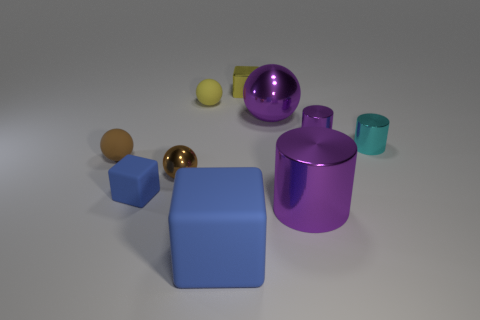Subtract all cyan cubes. How many purple cylinders are left? 2 Subtract 1 balls. How many balls are left? 3 Subtract all yellow balls. How many balls are left? 3 Subtract all large metal balls. How many balls are left? 3 Subtract all cyan balls. Subtract all blue cylinders. How many balls are left? 4 Subtract all blocks. How many objects are left? 7 Add 3 purple cylinders. How many purple cylinders exist? 5 Subtract 1 yellow cubes. How many objects are left? 9 Subtract all yellow balls. Subtract all tiny cyan cylinders. How many objects are left? 8 Add 3 yellow matte balls. How many yellow matte balls are left? 4 